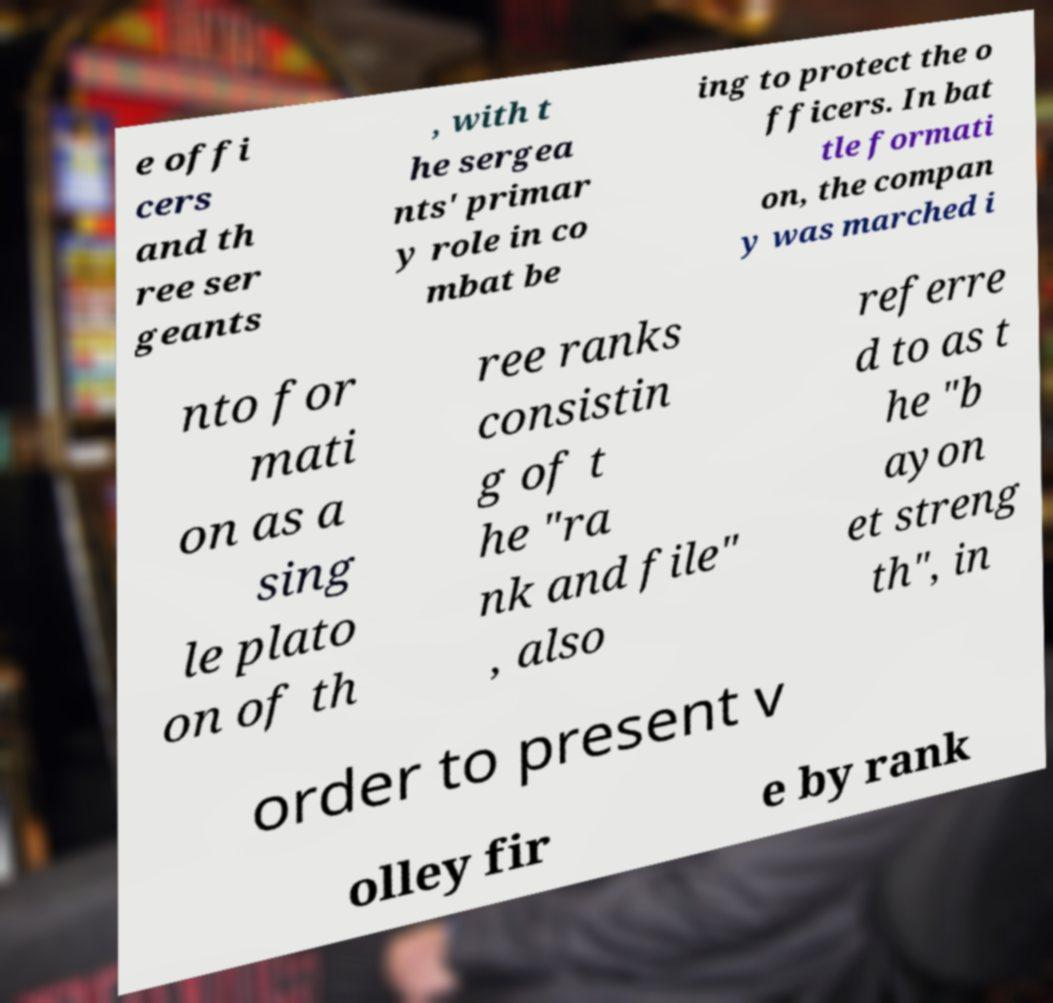Could you assist in decoding the text presented in this image and type it out clearly? e offi cers and th ree ser geants , with t he sergea nts' primar y role in co mbat be ing to protect the o fficers. In bat tle formati on, the compan y was marched i nto for mati on as a sing le plato on of th ree ranks consistin g of t he "ra nk and file" , also referre d to as t he "b ayon et streng th", in order to present v olley fir e by rank 